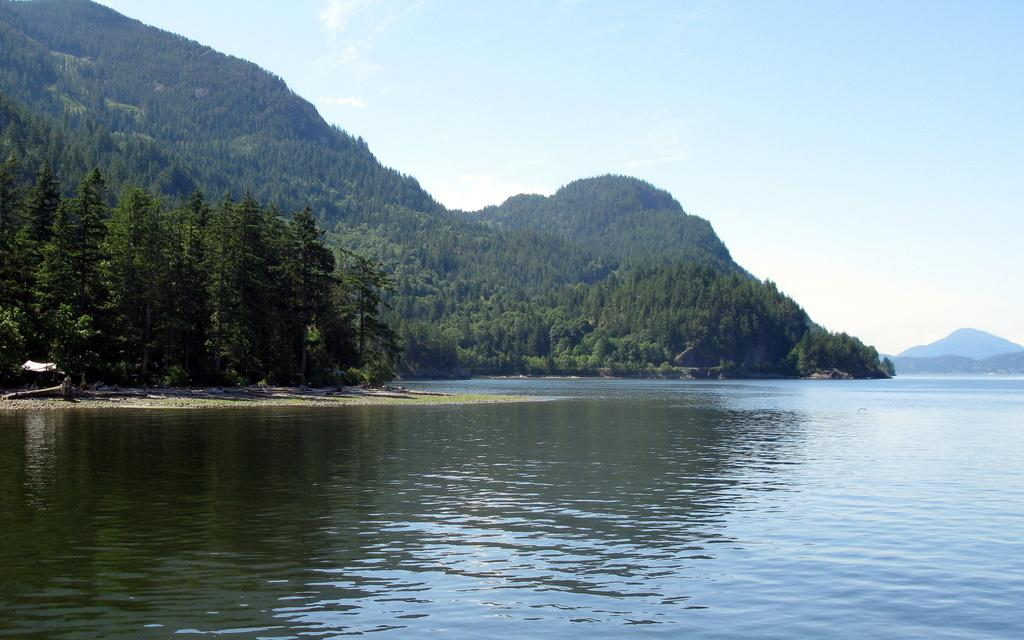What is one of the main elements in the picture? There is water in the picture. What type of natural features can be seen in the image? There are trees and hills in the picture. How would you describe the sky in the image? The sky is blue and cloudy. What flavor of ice cream is being distributed in the picture? There is no ice cream or distribution of any kind present in the image. 